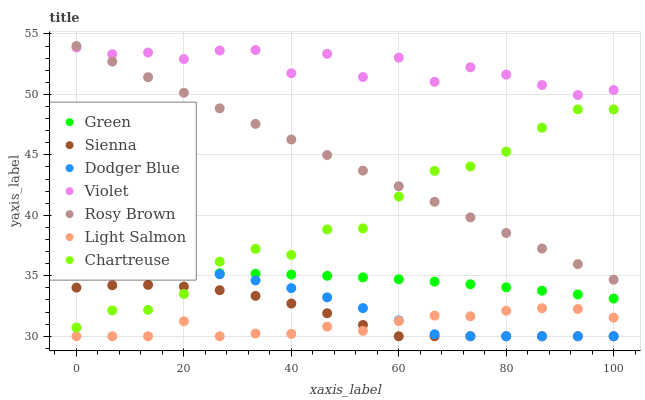Does Light Salmon have the minimum area under the curve?
Answer yes or no. Yes. Does Violet have the maximum area under the curve?
Answer yes or no. Yes. Does Rosy Brown have the minimum area under the curve?
Answer yes or no. No. Does Rosy Brown have the maximum area under the curve?
Answer yes or no. No. Is Rosy Brown the smoothest?
Answer yes or no. Yes. Is Violet the roughest?
Answer yes or no. Yes. Is Sienna the smoothest?
Answer yes or no. No. Is Sienna the roughest?
Answer yes or no. No. Does Light Salmon have the lowest value?
Answer yes or no. Yes. Does Rosy Brown have the lowest value?
Answer yes or no. No. Does Rosy Brown have the highest value?
Answer yes or no. Yes. Does Sienna have the highest value?
Answer yes or no. No. Is Sienna less than Violet?
Answer yes or no. Yes. Is Green greater than Sienna?
Answer yes or no. Yes. Does Green intersect Dodger Blue?
Answer yes or no. Yes. Is Green less than Dodger Blue?
Answer yes or no. No. Is Green greater than Dodger Blue?
Answer yes or no. No. Does Sienna intersect Violet?
Answer yes or no. No. 